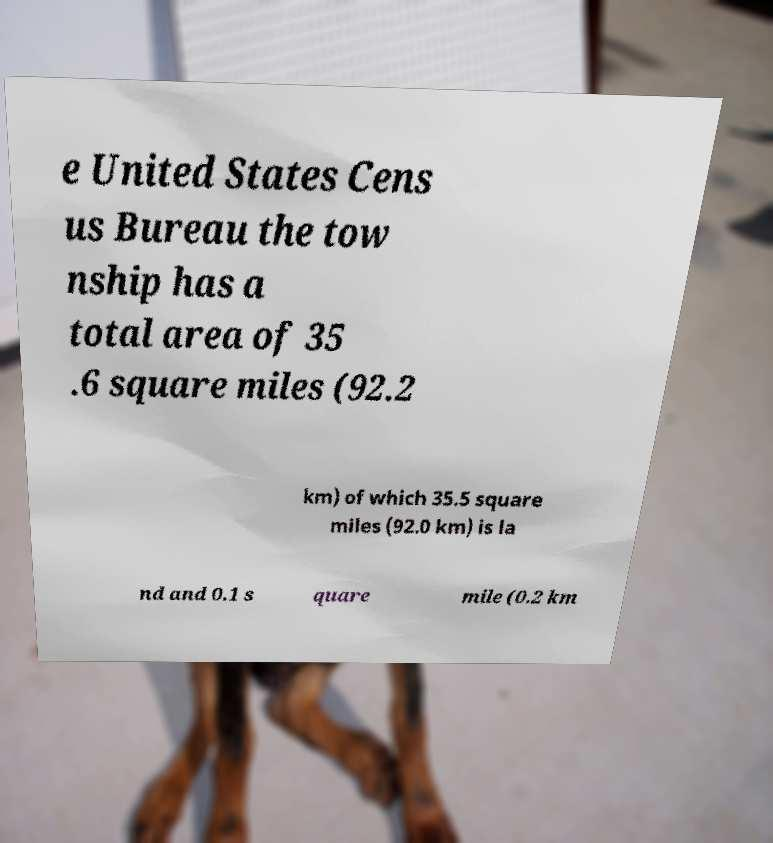Can you accurately transcribe the text from the provided image for me? e United States Cens us Bureau the tow nship has a total area of 35 .6 square miles (92.2 km) of which 35.5 square miles (92.0 km) is la nd and 0.1 s quare mile (0.2 km 